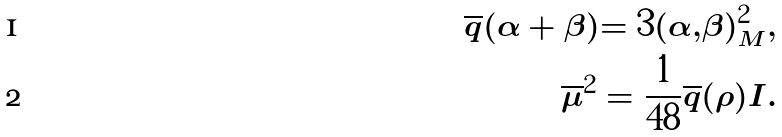<formula> <loc_0><loc_0><loc_500><loc_500>\overline { q } ( \alpha + \beta ) = 3 ( \alpha , \beta ) ^ { 2 } _ { M } , \\ \overline { \mu } ^ { 2 } = \frac { 1 } { 4 8 } \overline { q } ( \rho ) I .</formula> 